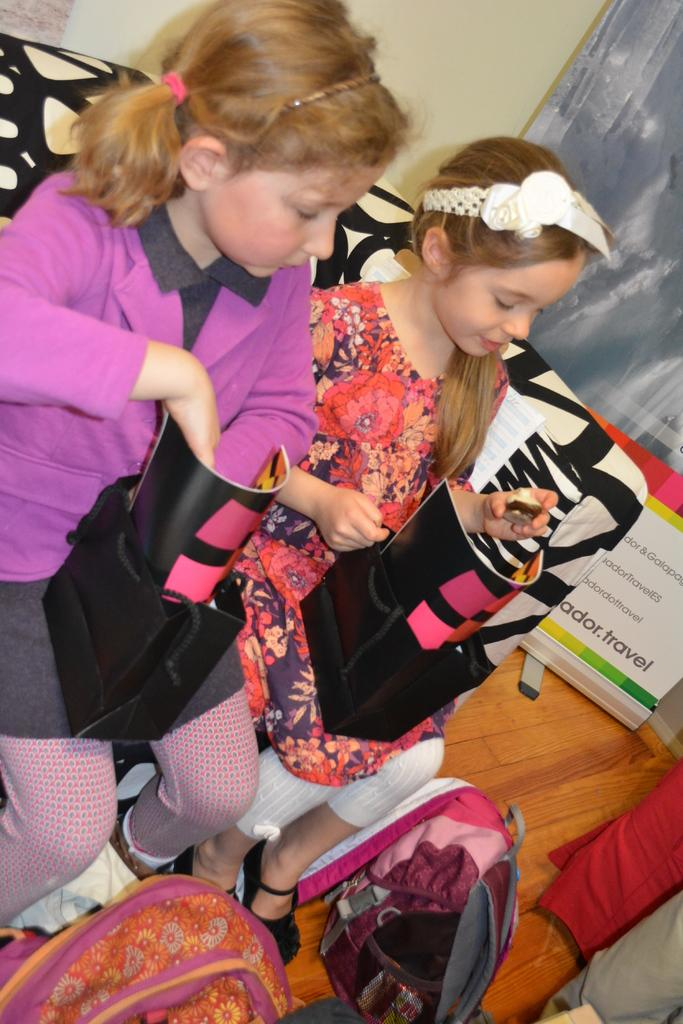How many girls are present in the image? There are two girls in the image. What are the girls doing in the image? The girls are sitting. What are the girls holding in the image? The girls are holding black-colored bags. How many bags can be seen in the image? There are two bags in the image. What can be seen on the floor in the image? The floor is visible in the image, and there are clothes on it. What is hanging on the wall in the background of the image? There is a banner in the image. What type of beds can be seen in the image? There are no beds present in the image. What are the girls talking about in the image? The image does not provide any information about what the girls might be talking about. 